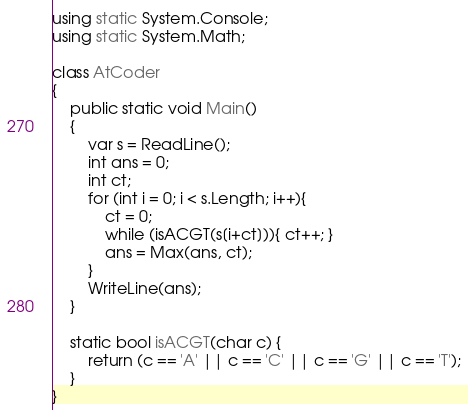Convert code to text. <code><loc_0><loc_0><loc_500><loc_500><_C#_>using static System.Console;
using static System.Math;

class AtCoder 
{
    public static void Main()
    {
        var s = ReadLine();
        int ans = 0;
        int ct;
        for (int i = 0; i < s.Length; i++){
            ct = 0;    
            while (isACGT(s[i+ct])){ ct++; }
            ans = Max(ans, ct);
        }
        WriteLine(ans);
    }

    static bool isACGT(char c) {
        return (c == 'A' || c == 'C' || c == 'G' || c == 'T');
    }
}</code> 